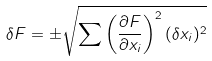<formula> <loc_0><loc_0><loc_500><loc_500>\delta F = \pm \sqrt { \sum \left ( \frac { \partial F } { \partial x _ { i } } \right ) ^ { 2 } ( \delta x _ { i } ) ^ { 2 } }</formula> 